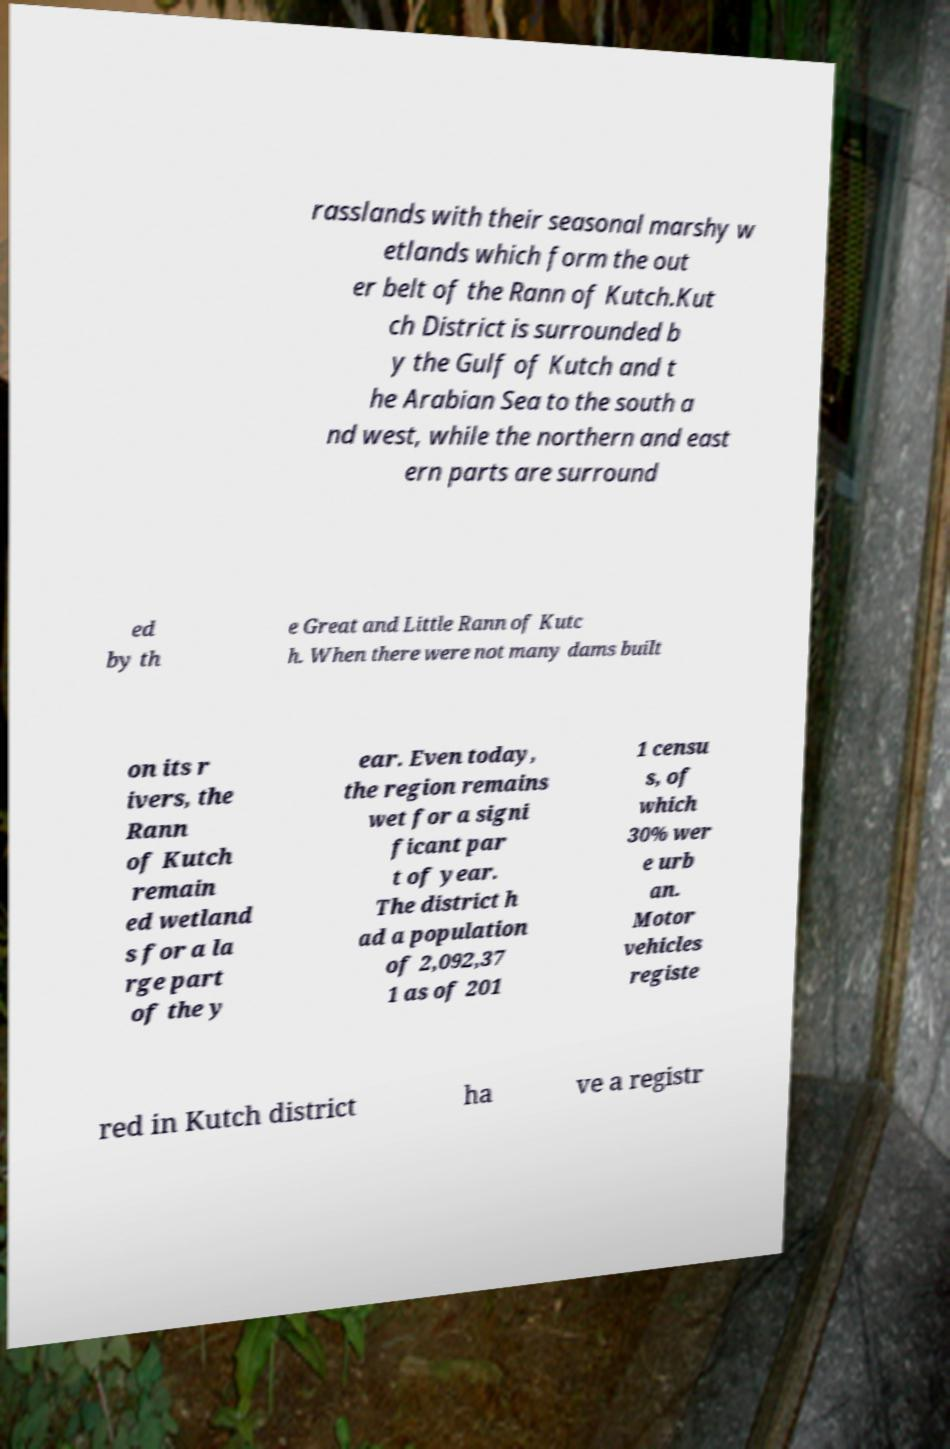I need the written content from this picture converted into text. Can you do that? rasslands with their seasonal marshy w etlands which form the out er belt of the Rann of Kutch.Kut ch District is surrounded b y the Gulf of Kutch and t he Arabian Sea to the south a nd west, while the northern and east ern parts are surround ed by th e Great and Little Rann of Kutc h. When there were not many dams built on its r ivers, the Rann of Kutch remain ed wetland s for a la rge part of the y ear. Even today, the region remains wet for a signi ficant par t of year. The district h ad a population of 2,092,37 1 as of 201 1 censu s, of which 30% wer e urb an. Motor vehicles registe red in Kutch district ha ve a registr 